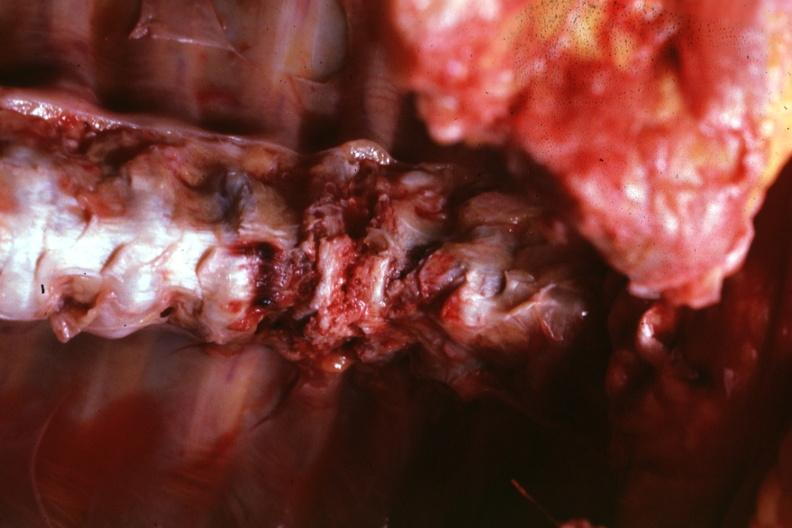what is present?
Answer the question using a single word or phrase. Joints 